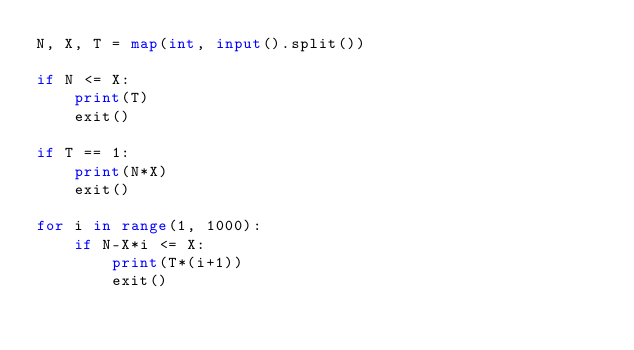<code> <loc_0><loc_0><loc_500><loc_500><_Python_>N, X, T = map(int, input().split())

if N <= X:
    print(T)
    exit()

if T == 1:
    print(N*X)
    exit()

for i in range(1, 1000):
    if N-X*i <= X:
        print(T*(i+1))
        exit()

</code> 